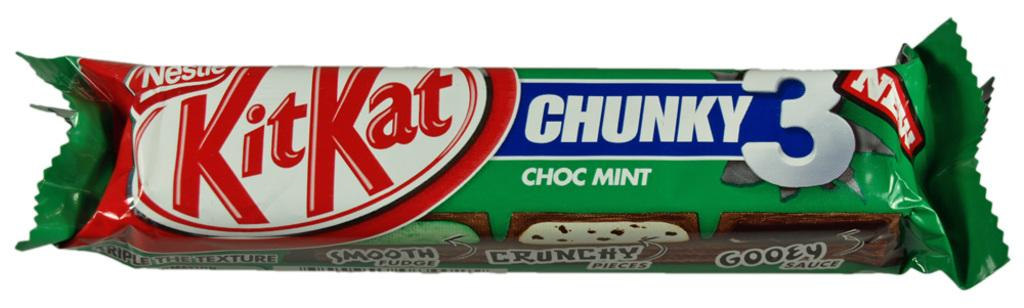What is the main subject of the image? The main subject of the image is a chocolate. Can you describe the location of the chocolate in the image? The chocolate is in the center of the image. How many kittens are present in the image? There are no kittens present in the image; it features a chocolate. What type of education is being provided in the image? There is no indication of education in the image, as it only features a chocolate. 